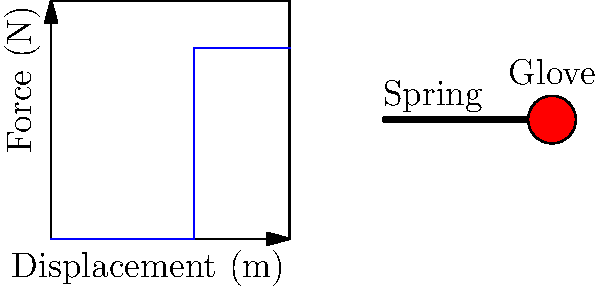In your latest comedy film, you're planning a scene with a spring-loaded boxing glove gag. The graph shows the force-displacement relationship of the spring mechanism. If the glove travels 3 meters before hitting the unsuspecting character, what is the force exerted by the spring at the moment of impact? How might this information influence your comedic timing and actor positioning for maximum laughs? To solve this problem and create the perfect comedic moment, let's break it down step-by-step:

1. Analyze the force-displacement graph:
   - The graph shows a linear relationship up to 3 meters, then a constant force.
   - The y-axis represents force (N), and the x-axis represents displacement (m).

2. Determine the displacement at impact:
   - The question states the glove travels 3 meters before hitting the character.

3. Find the corresponding force at 3 meters displacement:
   - Trace a vertical line from 3 meters on the x-axis to the graph line.
   - The intersection point corresponds to 4 N on the y-axis.

4. Interpret the result:
   - The force exerted by the spring at the moment of impact is 4 N.

5. Comedic timing and actor positioning:
   - Knowing the force helps determine the intensity of the actor's reaction.
   - A 4 N force is relatively gentle, so the actor's reaction should be more surprised than pained.
   - Position the actor exactly 3 meters from the spring mechanism for precise timing.
   - Consider a delayed reaction for added comedic effect, given the mild force.

By understanding the physics of the gag, you can choreograph the scene for maximum comedic impact, balancing the surprise of the sudden glove appearance with a slightly exaggerated but not overly dramatic reaction from the actor.
Answer: 4 N 